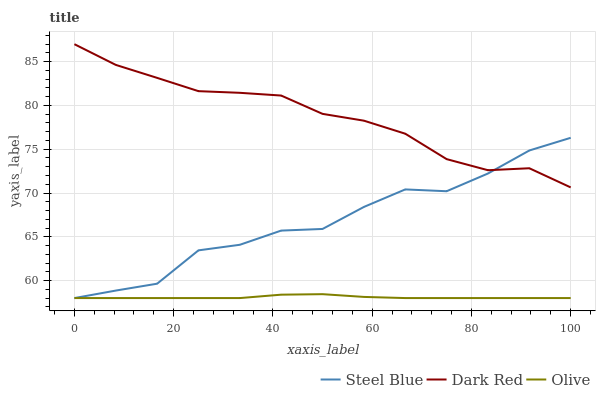Does Olive have the minimum area under the curve?
Answer yes or no. Yes. Does Dark Red have the maximum area under the curve?
Answer yes or no. Yes. Does Steel Blue have the minimum area under the curve?
Answer yes or no. No. Does Steel Blue have the maximum area under the curve?
Answer yes or no. No. Is Olive the smoothest?
Answer yes or no. Yes. Is Steel Blue the roughest?
Answer yes or no. Yes. Is Dark Red the smoothest?
Answer yes or no. No. Is Dark Red the roughest?
Answer yes or no. No. Does Olive have the lowest value?
Answer yes or no. Yes. Does Dark Red have the lowest value?
Answer yes or no. No. Does Dark Red have the highest value?
Answer yes or no. Yes. Does Steel Blue have the highest value?
Answer yes or no. No. Is Olive less than Dark Red?
Answer yes or no. Yes. Is Dark Red greater than Olive?
Answer yes or no. Yes. Does Steel Blue intersect Olive?
Answer yes or no. Yes. Is Steel Blue less than Olive?
Answer yes or no. No. Is Steel Blue greater than Olive?
Answer yes or no. No. Does Olive intersect Dark Red?
Answer yes or no. No. 